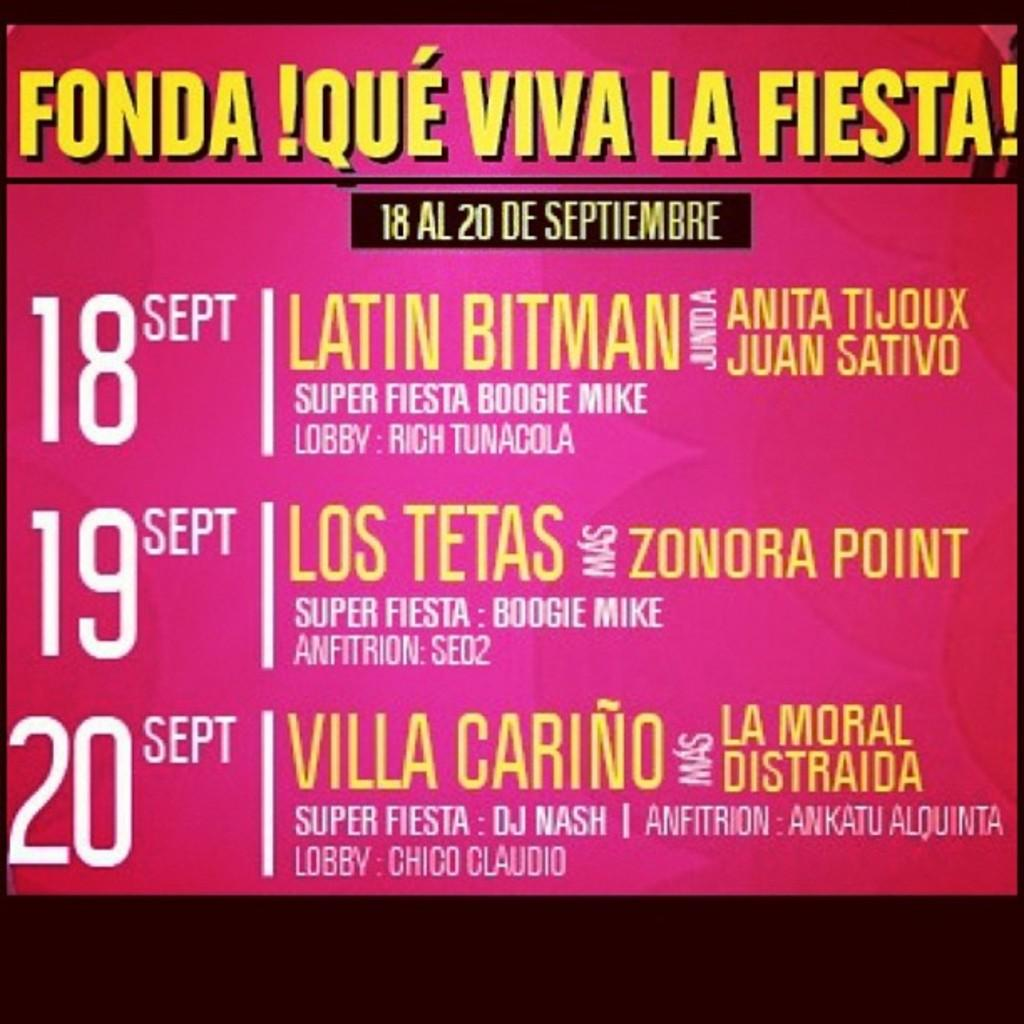<image>
Relay a brief, clear account of the picture shown. On the 18th of September the Latin Bitman is playing at this event. 